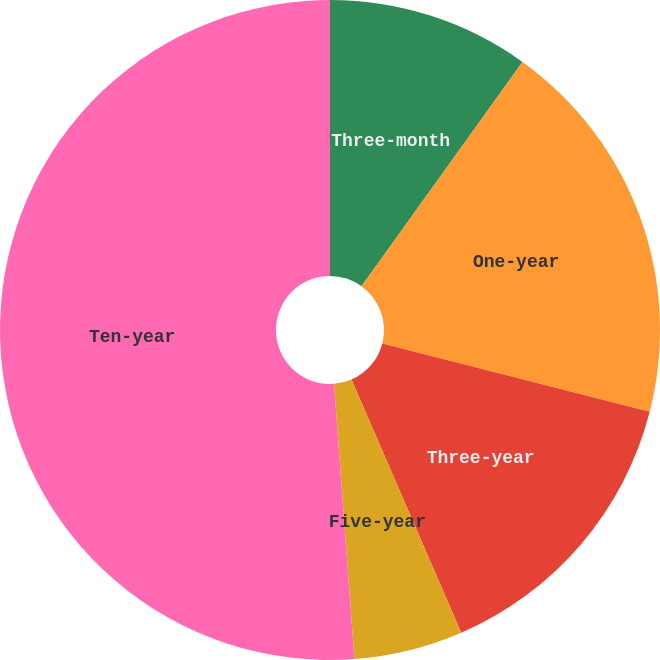Convert chart to OTSL. <chart><loc_0><loc_0><loc_500><loc_500><pie_chart><fcel>Three-month<fcel>One-year<fcel>Three-year<fcel>Five-year<fcel>Ten-year<nl><fcel>9.91%<fcel>19.08%<fcel>14.5%<fcel>5.33%<fcel>51.18%<nl></chart> 